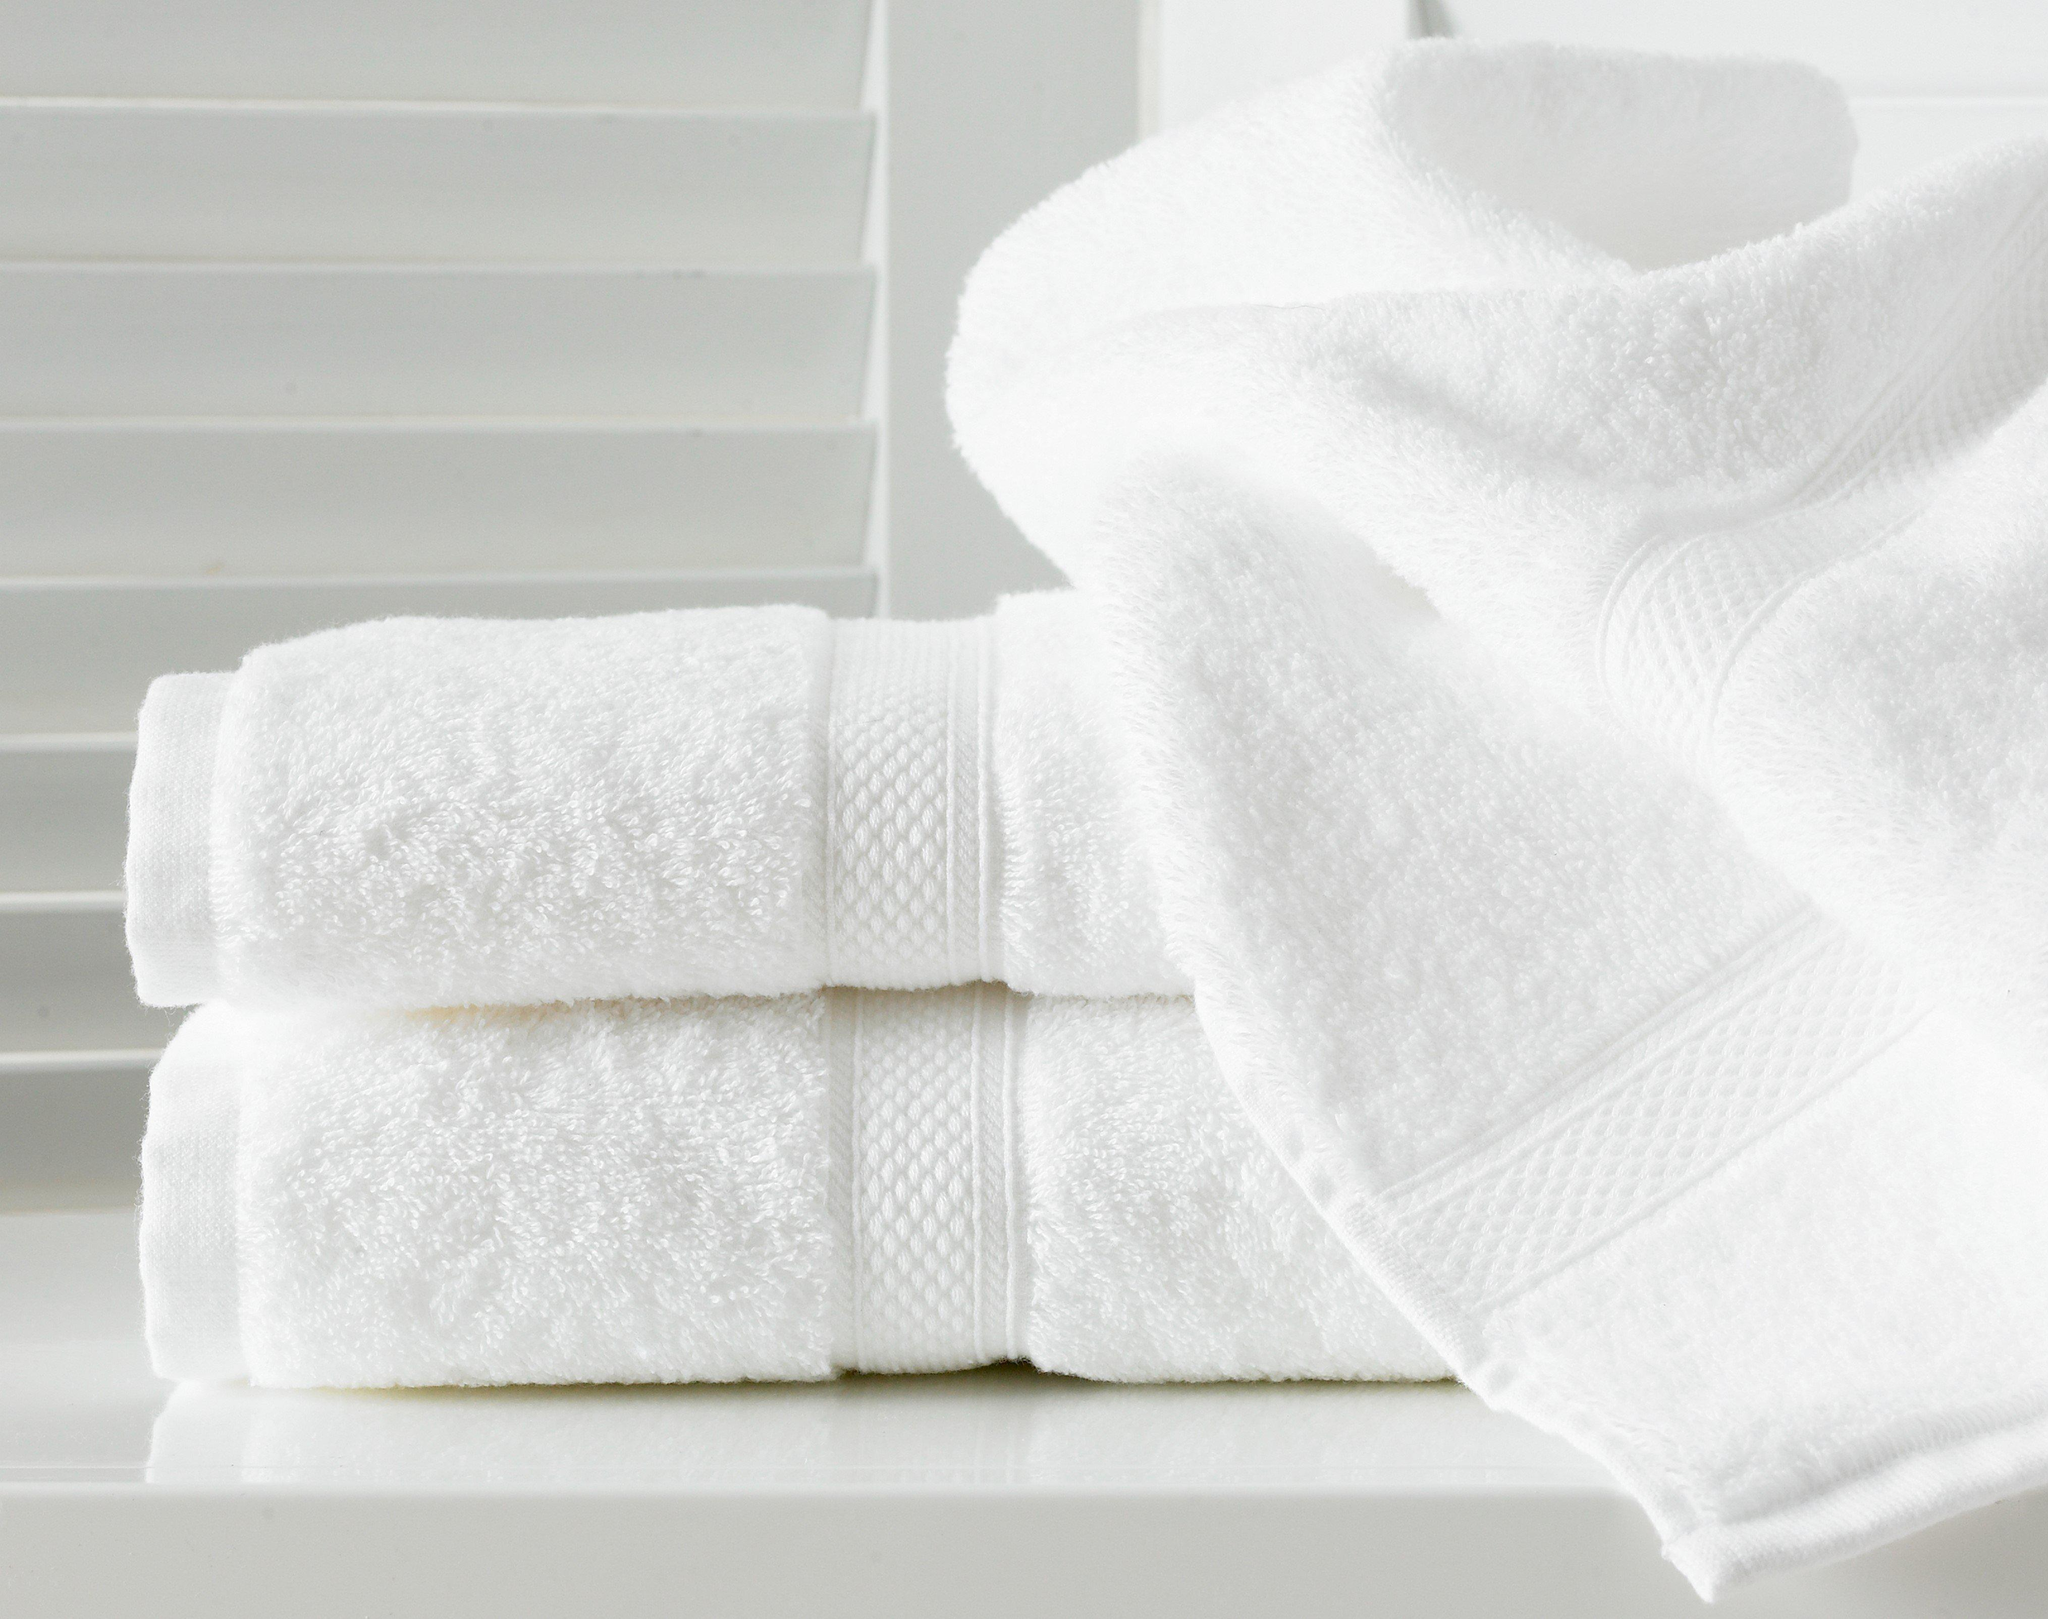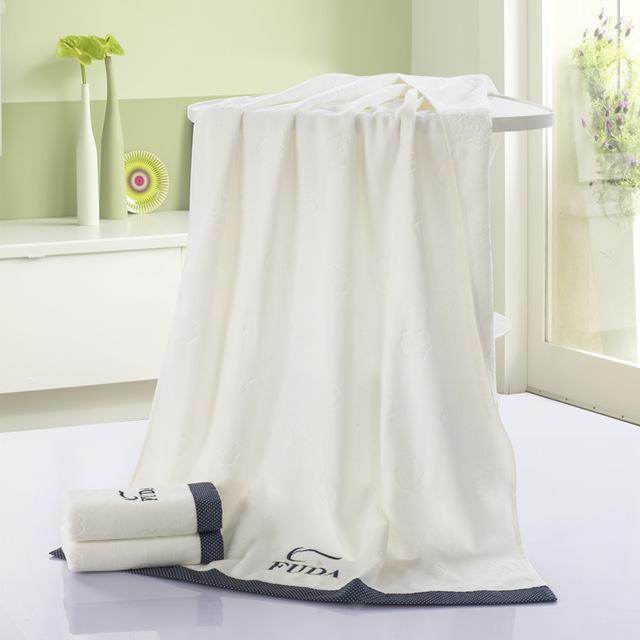The first image is the image on the left, the second image is the image on the right. Given the left and right images, does the statement "In the left image there are three folded towels stacked together." hold true? Answer yes or no. No. The first image is the image on the left, the second image is the image on the right. Given the left and right images, does the statement "The left and right image contains the same number folded towels." hold true? Answer yes or no. Yes. 